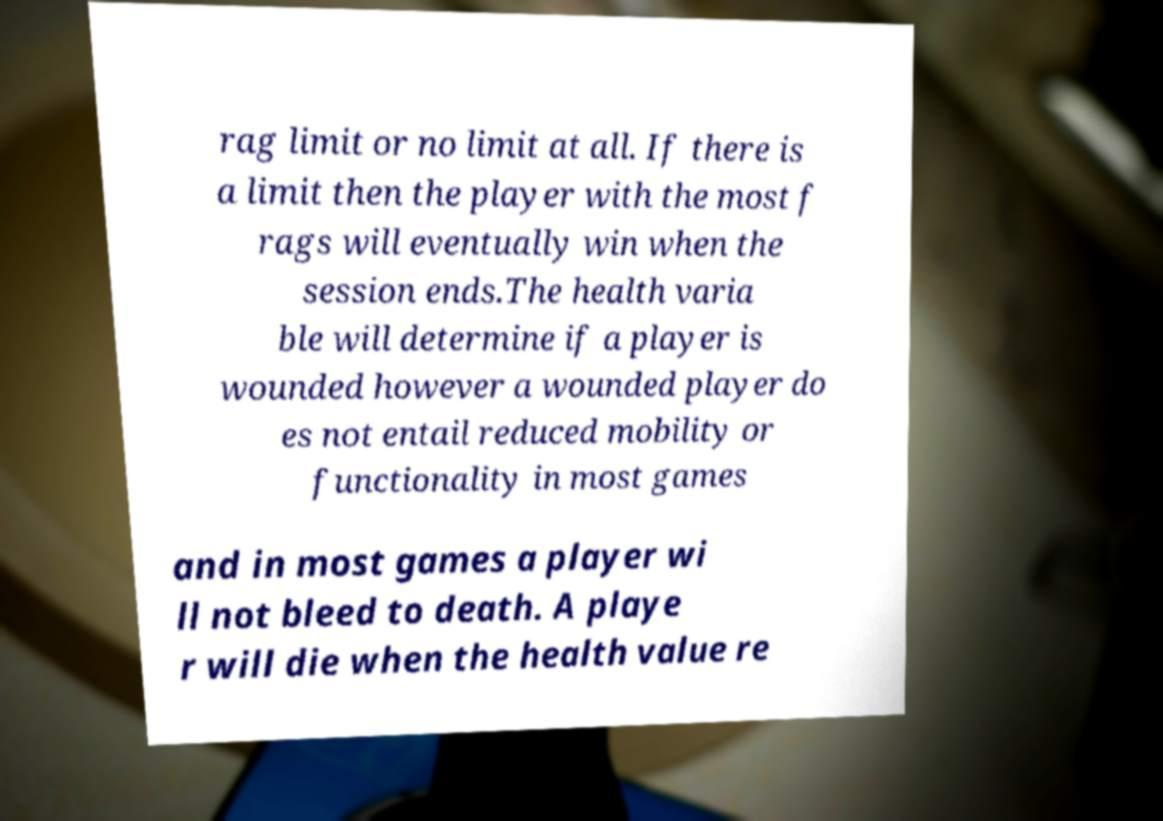Can you accurately transcribe the text from the provided image for me? rag limit or no limit at all. If there is a limit then the player with the most f rags will eventually win when the session ends.The health varia ble will determine if a player is wounded however a wounded player do es not entail reduced mobility or functionality in most games and in most games a player wi ll not bleed to death. A playe r will die when the health value re 